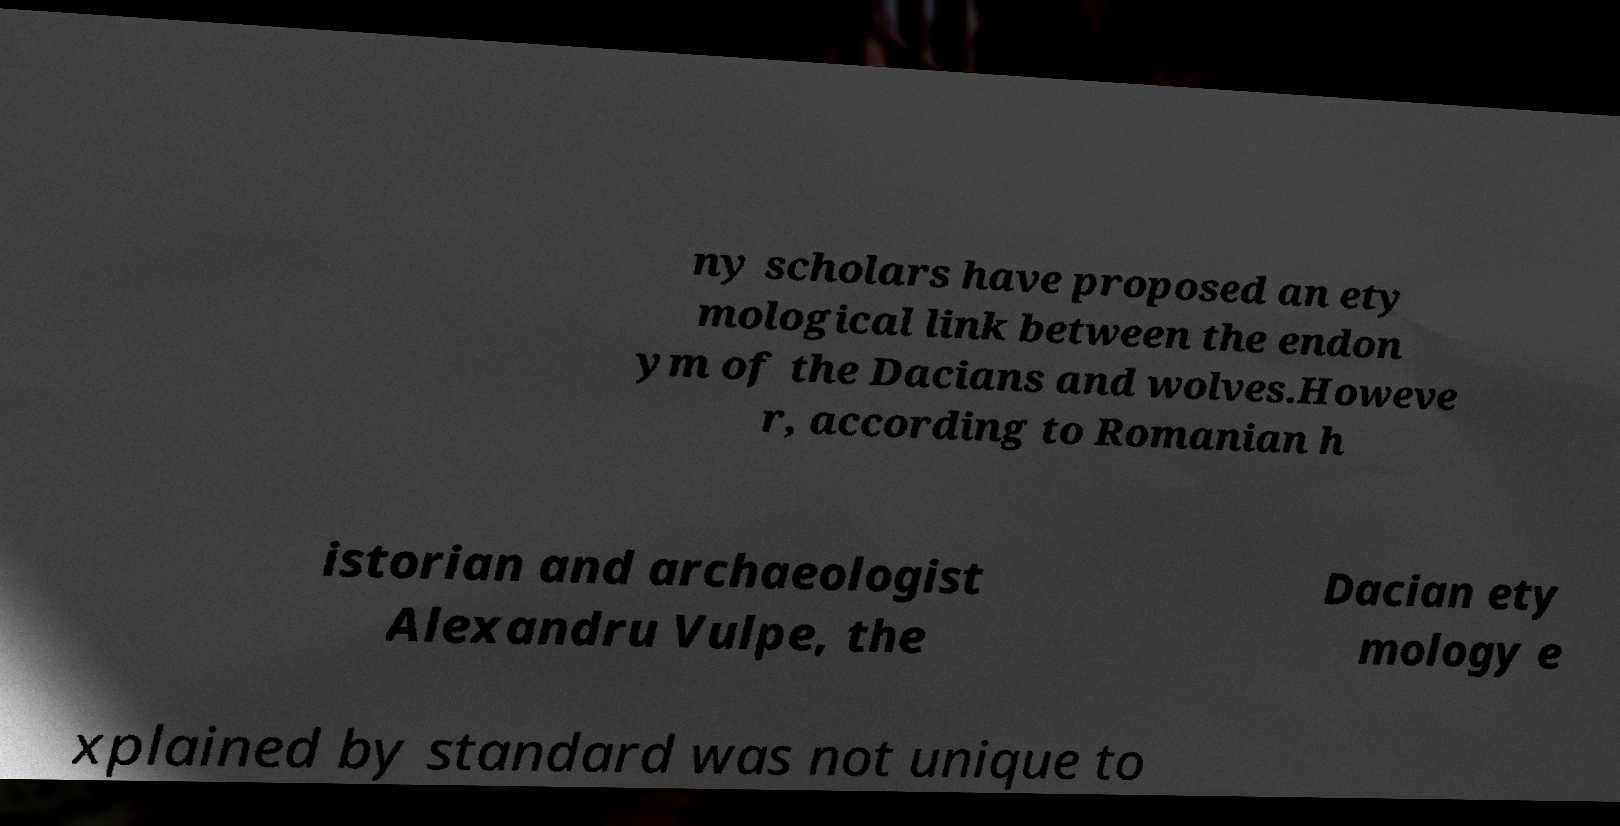Could you assist in decoding the text presented in this image and type it out clearly? ny scholars have proposed an ety mological link between the endon ym of the Dacians and wolves.Howeve r, according to Romanian h istorian and archaeologist Alexandru Vulpe, the Dacian ety mology e xplained by standard was not unique to 